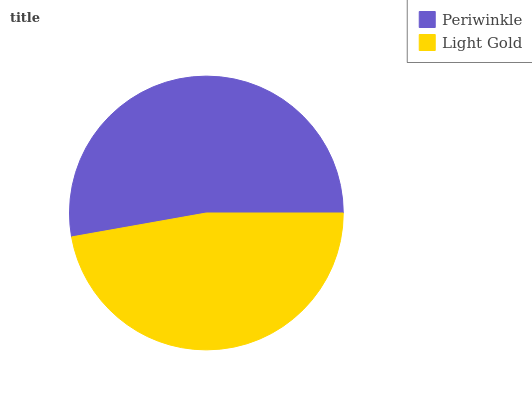Is Light Gold the minimum?
Answer yes or no. Yes. Is Periwinkle the maximum?
Answer yes or no. Yes. Is Light Gold the maximum?
Answer yes or no. No. Is Periwinkle greater than Light Gold?
Answer yes or no. Yes. Is Light Gold less than Periwinkle?
Answer yes or no. Yes. Is Light Gold greater than Periwinkle?
Answer yes or no. No. Is Periwinkle less than Light Gold?
Answer yes or no. No. Is Periwinkle the high median?
Answer yes or no. Yes. Is Light Gold the low median?
Answer yes or no. Yes. Is Light Gold the high median?
Answer yes or no. No. Is Periwinkle the low median?
Answer yes or no. No. 